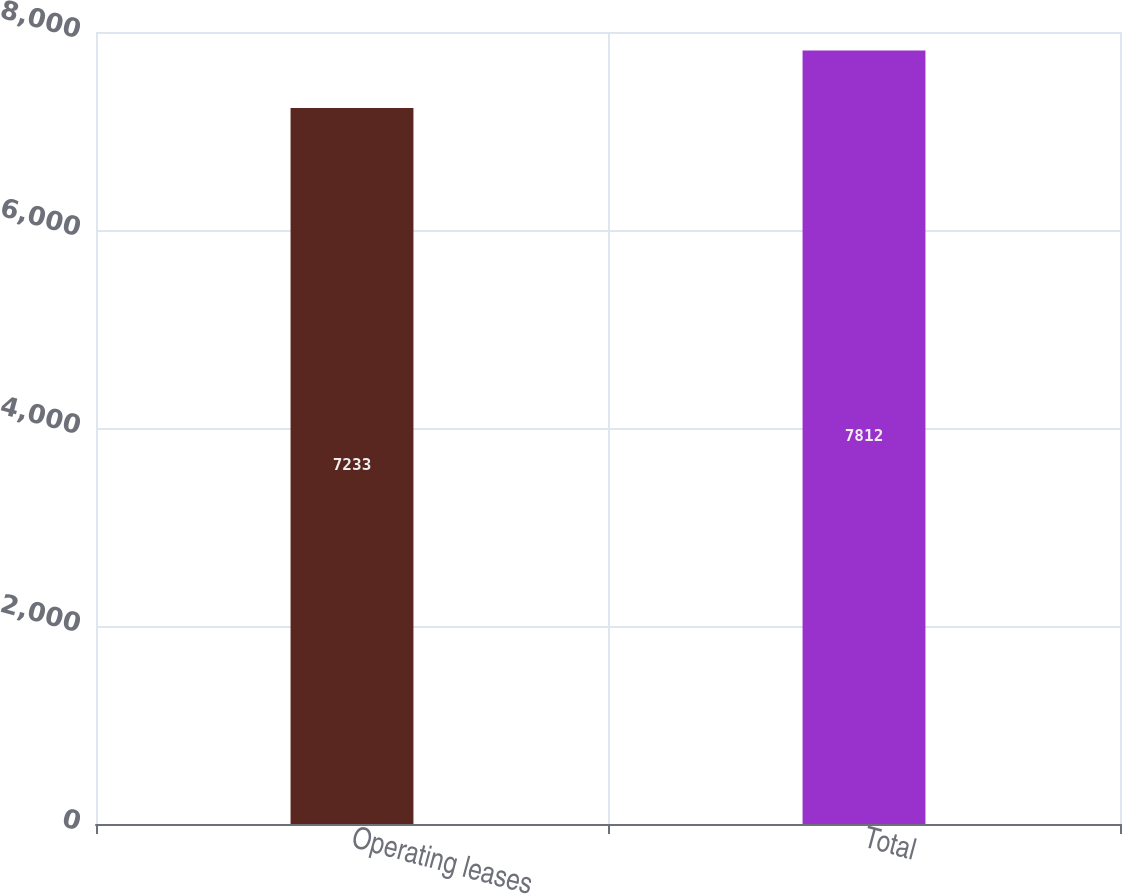Convert chart. <chart><loc_0><loc_0><loc_500><loc_500><bar_chart><fcel>Operating leases<fcel>Total<nl><fcel>7233<fcel>7812<nl></chart> 